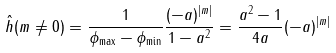Convert formula to latex. <formula><loc_0><loc_0><loc_500><loc_500>\hat { h } ( m \neq 0 ) = \frac { 1 } { \phi _ { \max } - \phi _ { \min } } \frac { ( - a ) ^ { | m | } } { 1 - a ^ { 2 } } = \frac { a ^ { 2 } - 1 } { 4 a } ( - a ) ^ { | m | }</formula> 